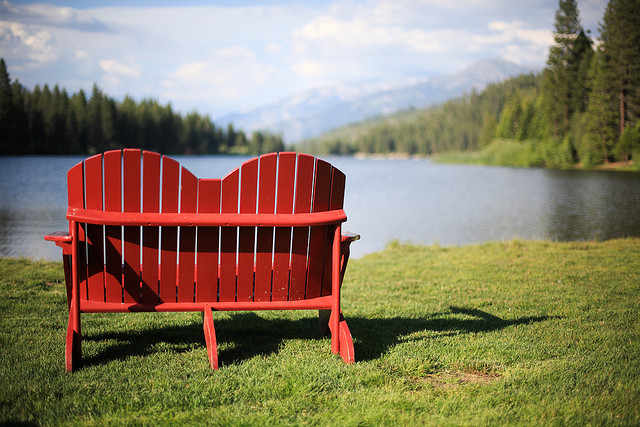Describe the setting and mood of this location. The location is a picturesque lakeside area surrounded by lush forests and distant mountains. The mood here is tranquil and peaceful, inviting visitors to relax and take in the natural beauty. The red bench facing the lake adds a charming touch and seems like an ideal spot for quiet contemplation or enjoying a serene moment with a loved one. 